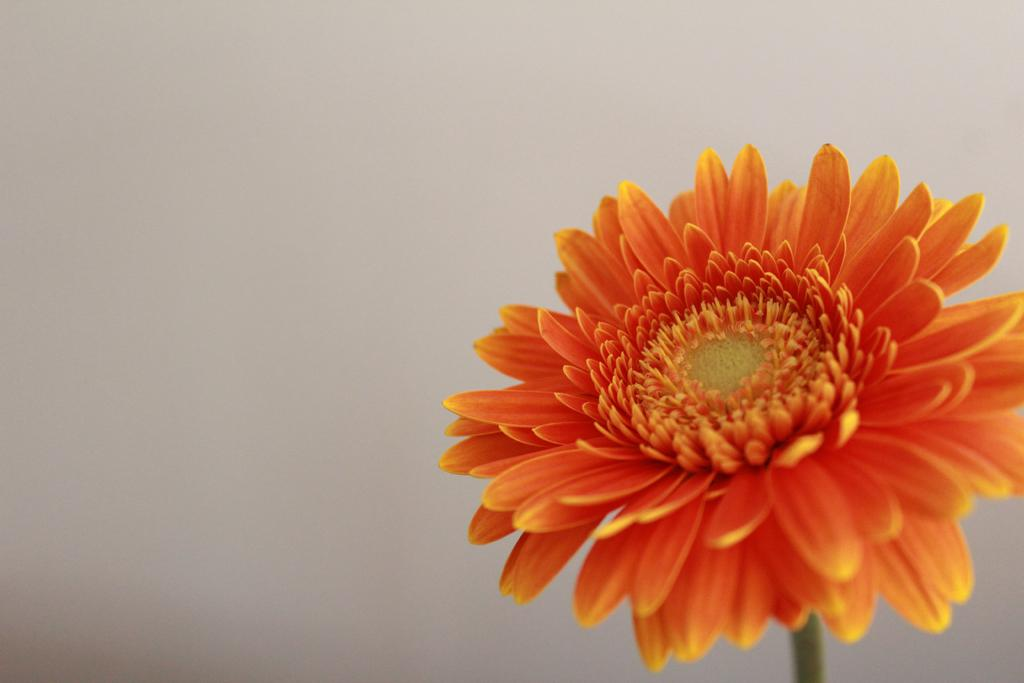What type of flower is in the image? There is an orange color flower in the image. What color is the background of the image? The background of the image is white. Where is the mailbox located in the image? There is no mailbox present in the image. What type of produce can be seen growing in the image? There is no produce visible in the image; it only features an orange color flower. 